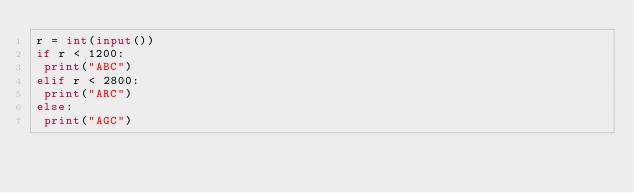Convert code to text. <code><loc_0><loc_0><loc_500><loc_500><_Python_>r = int(input())
if r < 1200:
 print("ABC")
elif r < 2800:
 print("ARC")
else:
 print("AGC")</code> 